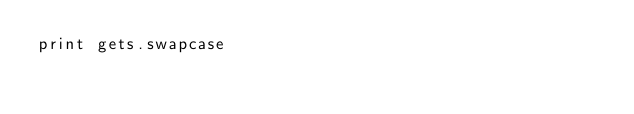Convert code to text. <code><loc_0><loc_0><loc_500><loc_500><_Ruby_>print gets.swapcase</code> 